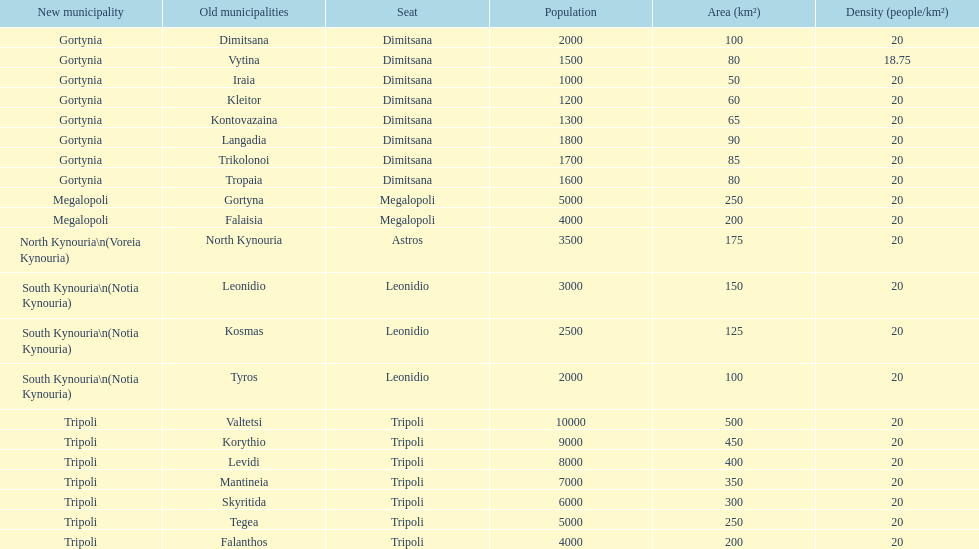Parse the table in full. {'header': ['New municipality', 'Old municipalities', 'Seat', 'Population', 'Area (km²)', 'Density (people/km²)'], 'rows': [['Gortynia', 'Dimitsana', 'Dimitsana', '2000', '100', '20'], ['Gortynia', 'Vytina', 'Dimitsana', '1500', '80', '18.75'], ['Gortynia', 'Iraia', 'Dimitsana', '1000', '50', '20'], ['Gortynia', 'Kleitor', 'Dimitsana', '1200', '60', '20'], ['Gortynia', 'Kontovazaina', 'Dimitsana', '1300', '65', '20'], ['Gortynia', 'Langadia', 'Dimitsana', '1800', '90', '20'], ['Gortynia', 'Trikolonoi', 'Dimitsana', '1700', '85', '20'], ['Gortynia', 'Tropaia', 'Dimitsana', '1600', '80', '20'], ['Megalopoli', 'Gortyna', 'Megalopoli', '5000', '250', '20'], ['Megalopoli', 'Falaisia', 'Megalopoli', '4000', '200', '20'], ['North Kynouria\\n(Voreia Kynouria)', 'North Kynouria', 'Astros', '3500', '175', '20'], ['South Kynouria\\n(Notia Kynouria)', 'Leonidio', 'Leonidio', '3000', '150', '20'], ['South Kynouria\\n(Notia Kynouria)', 'Kosmas', 'Leonidio', '2500', '125', '20'], ['South Kynouria\\n(Notia Kynouria)', 'Tyros', 'Leonidio', '2000', '100', '20'], ['Tripoli', 'Valtetsi', 'Tripoli', '10000', '500', '20'], ['Tripoli', 'Korythio', 'Tripoli', '9000', '450', '20'], ['Tripoli', 'Levidi', 'Tripoli', '8000', '400', '20'], ['Tripoli', 'Mantineia', 'Tripoli', '7000', '350', '20'], ['Tripoli', 'Skyritida', 'Tripoli', '6000', '300', '20'], ['Tripoli', 'Tegea', 'Tripoli', '5000', '250', '20'], ['Tripoli', 'Falanthos', 'Tripoli', '4000', '200', '20']]} Is tripoli still considered a municipality in arcadia since its 2011 reformation? Yes. 